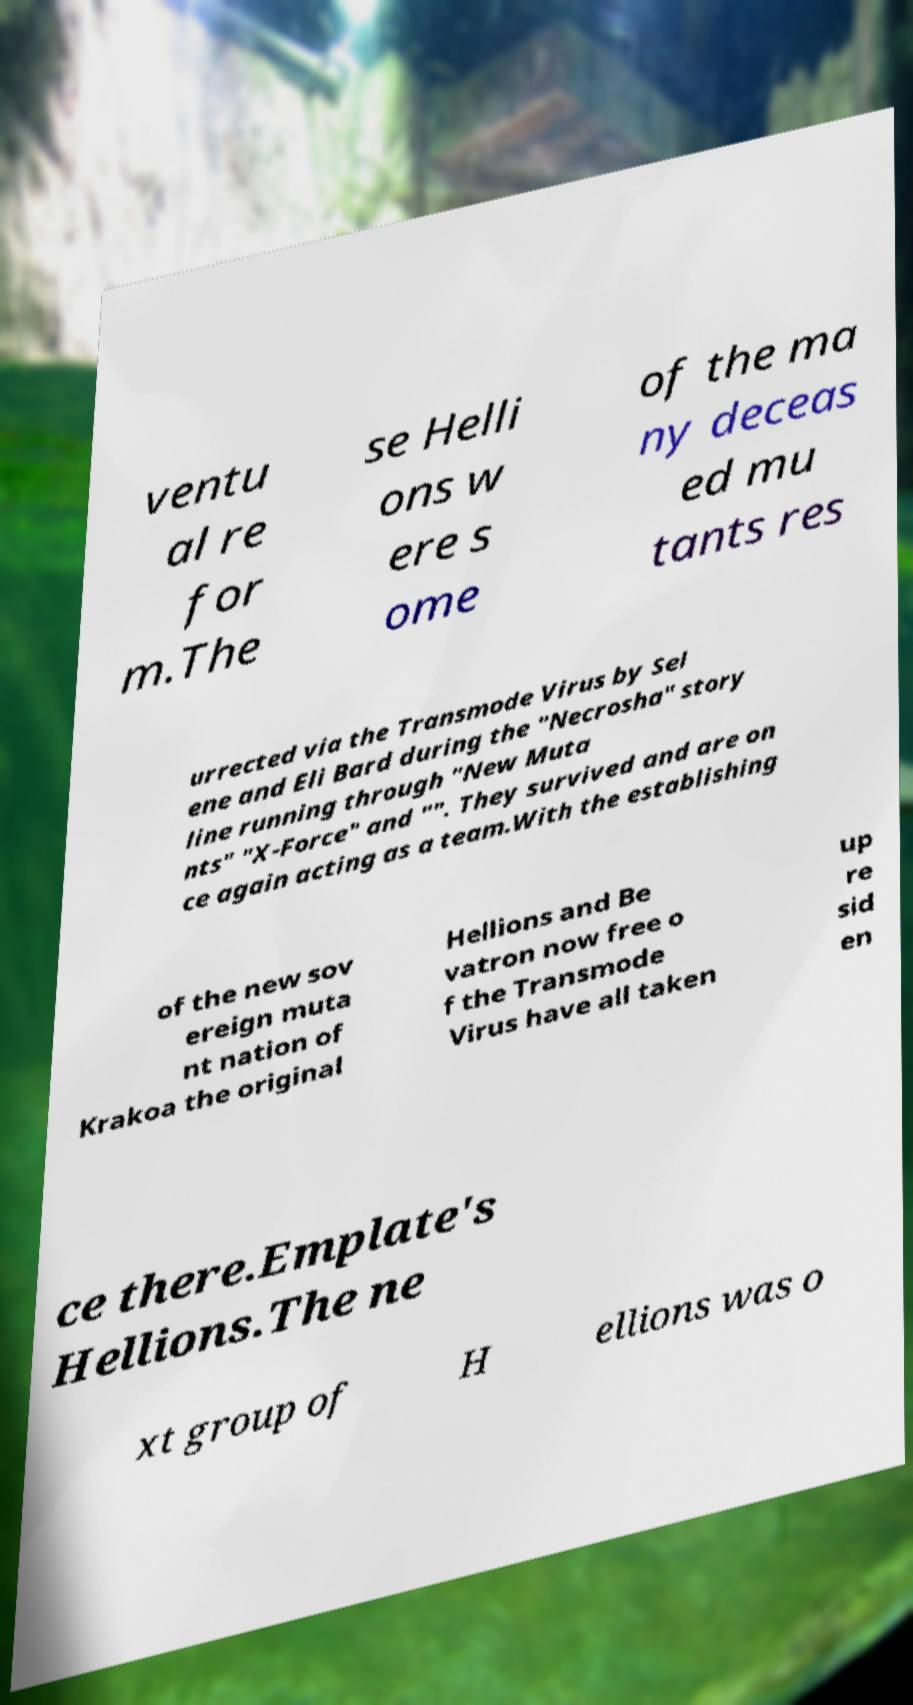Could you extract and type out the text from this image? ventu al re for m.The se Helli ons w ere s ome of the ma ny deceas ed mu tants res urrected via the Transmode Virus by Sel ene and Eli Bard during the "Necrosha" story line running through "New Muta nts" "X-Force" and "". They survived and are on ce again acting as a team.With the establishing of the new sov ereign muta nt nation of Krakoa the original Hellions and Be vatron now free o f the Transmode Virus have all taken up re sid en ce there.Emplate's Hellions.The ne xt group of H ellions was o 